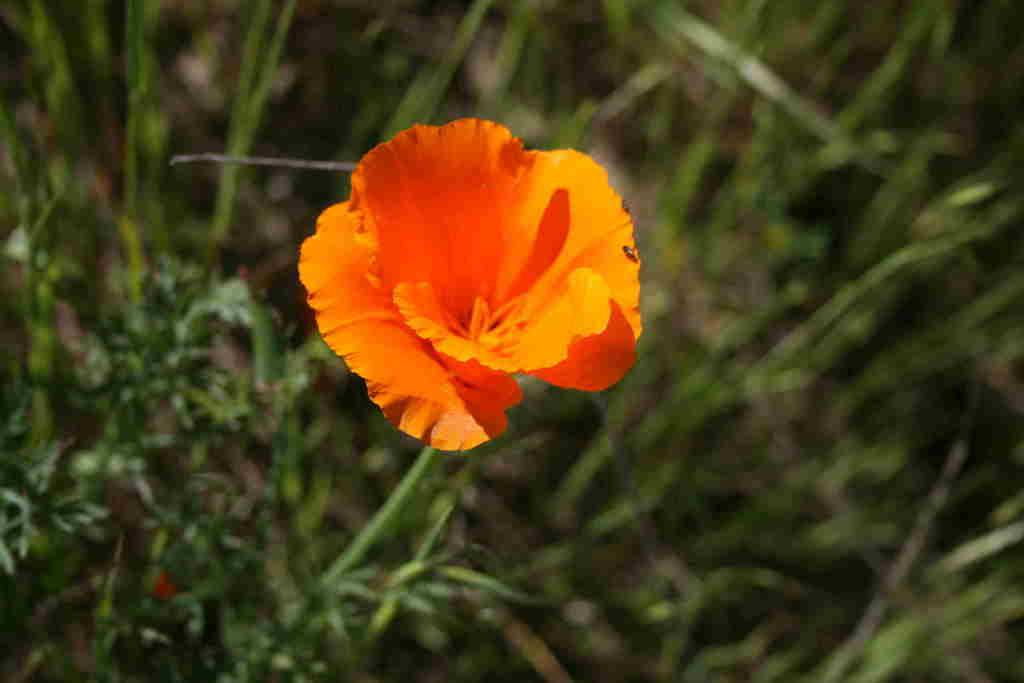What type of plant is visible in the image? There is a flower and a plant in the image. What type of vegetation is present in the image? There is grass in the image. What type of competition is taking place between the flower and the plant in the image? There is no competition between the flower and the plant in the image; they are both simply present in the image. 